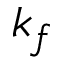<formula> <loc_0><loc_0><loc_500><loc_500>k _ { f }</formula> 